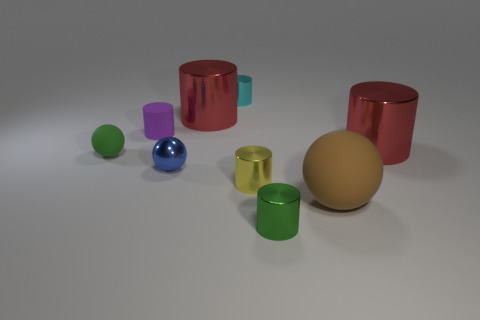There is a big metal cylinder left of the rubber sphere that is to the right of the tiny green ball; what is its color?
Ensure brevity in your answer.  Red. Are there fewer rubber things that are on the left side of the blue ball than big red things that are behind the tiny cyan metallic cylinder?
Offer a very short reply. No. What material is the thing that is the same color as the tiny rubber ball?
Offer a very short reply. Metal. What number of things are either things that are right of the green ball or tiny green balls?
Provide a succinct answer. 9. There is a red thing that is right of the green metallic object; is it the same size as the tiny purple thing?
Keep it short and to the point. No. Is the number of things behind the big brown rubber sphere less than the number of brown metallic cylinders?
Keep it short and to the point. No. There is a green sphere that is the same size as the blue ball; what material is it?
Provide a succinct answer. Rubber. What number of big things are either purple rubber cylinders or blue metal balls?
Your response must be concise. 0. How many things are either large metal things right of the small cyan object or small metal things that are to the right of the small cyan cylinder?
Offer a very short reply. 3. Is the number of blue cylinders less than the number of tiny yellow shiny cylinders?
Make the answer very short. Yes. 